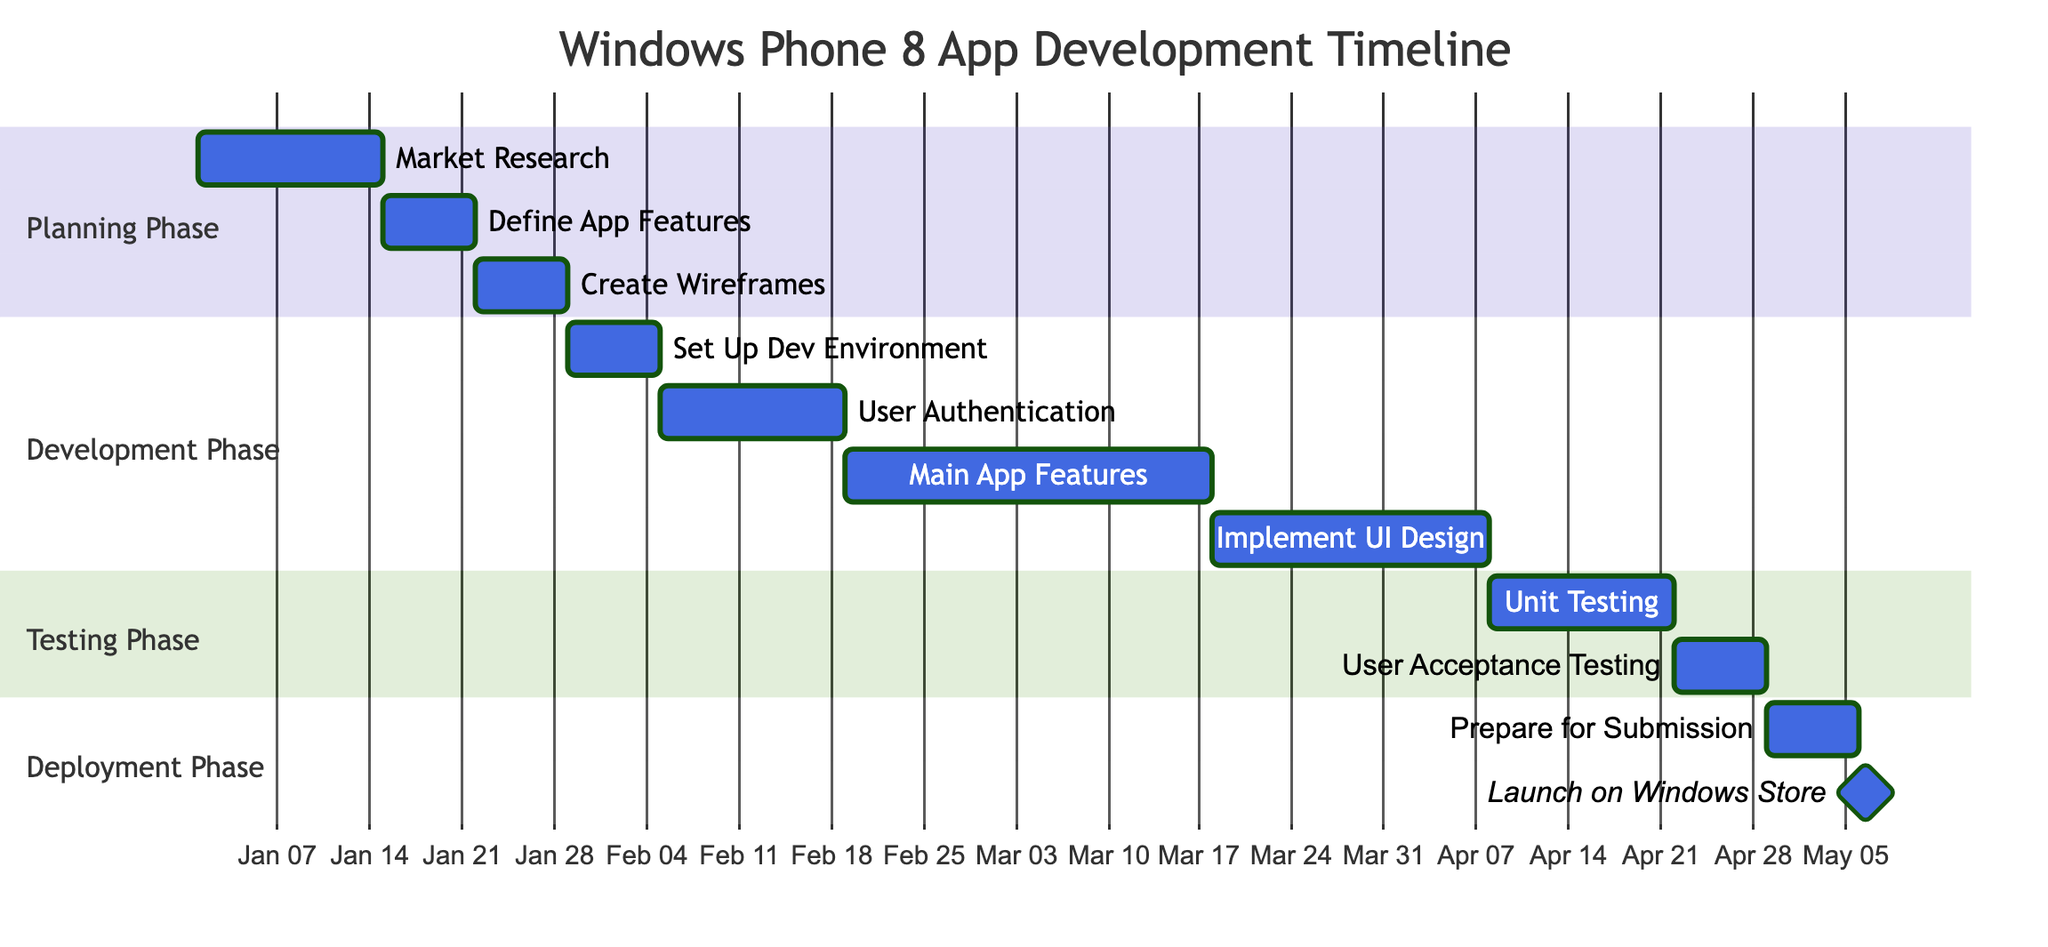What is the duration of the "Market Research" task? The task "Market Research" shows a duration of "2 weeks" in the planning phase of the Gantt chart.
Answer: 2 weeks When does the "Prepare App for Submission" task start? The "Prepare App for Submission" task starts on "2024-04-29," which is the start date shown in the Gantt chart.
Answer: 2024-04-29 How many tasks are there in the "Development Phase"? The "Development Phase" includes four distinct tasks listed in the Gantt chart: "Set Up Development Environment," "Develop User Authentication Module," "Build Main App Features," and "Implement UI Design."
Answer: 4 What is the end date of the "User Acceptance Testing" task? The "User Acceptance Testing" task ends on "2024-04-28," which is the end date specified in the Gantt chart.
Answer: 2024-04-28 Which task encompasses the longest duration? The task "Build Main App Features" has the longest duration of "4 weeks," making it the longest task in the entire project timeline as indicated in the Gantt chart.
Answer: 4 weeks What follows the "Unit Testing" task in the timeline? After the "Unit Testing" task, the "User Acceptance Testing" task immediately follows. This is evident from the ordering of tasks in the Testing Phase of the Gantt chart.
Answer: User Acceptance Testing How many phases are in the project timeline? The project timeline consists of four phases: "Planning Phase," "Development Phase," "Testing Phase," and "Deployment Phase." This count is derived from the sections shown in the Gantt chart.
Answer: 4 What is the relationship between "Define App Features" and "Create Wireframes"? "Create Wireframes" starts immediately after "Define App Features" ends, showing a sequential relationship where one task depends on another in the timeline.
Answer: Sequential What is the milestone at the end of the project timeline? The milestone at the end of the project timeline is "Launch on Windows Store," which is marked clearly in the Gantt chart as a milestone after the last task.
Answer: Launch on Windows Store 